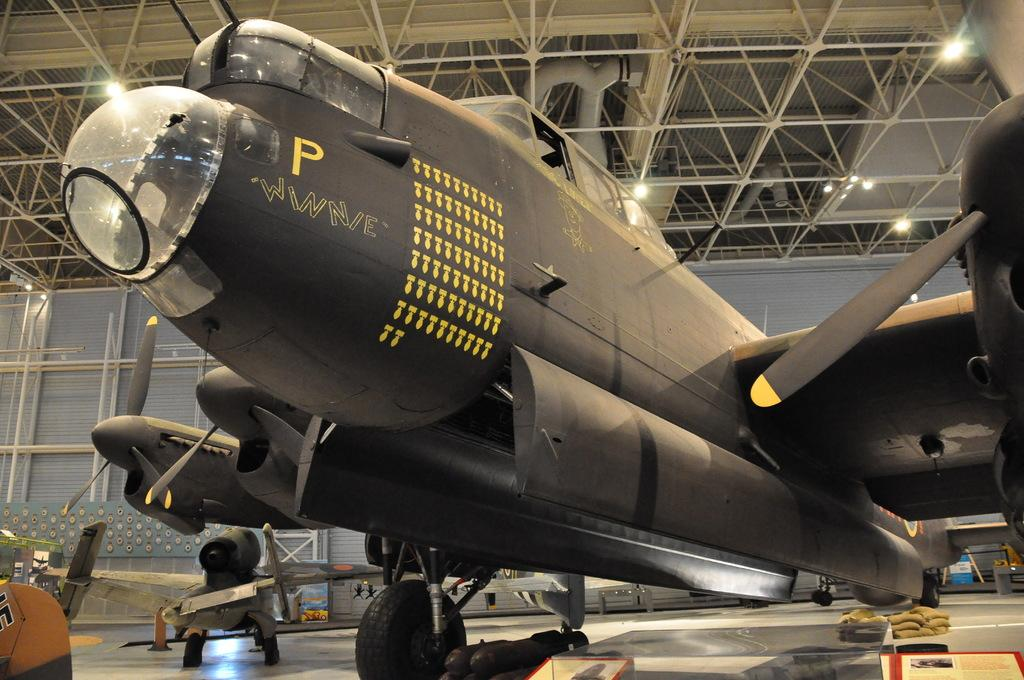What is present on the surface in the image? There are airplanes on the surface in the image. What can be seen in the background of the image? There are lights and rods in the background of the image. Can you tell me how many kittens are playing with the airplanes in the image? There are no kittens present in the image; it features airplanes on the surface and lights and rods in the background. 